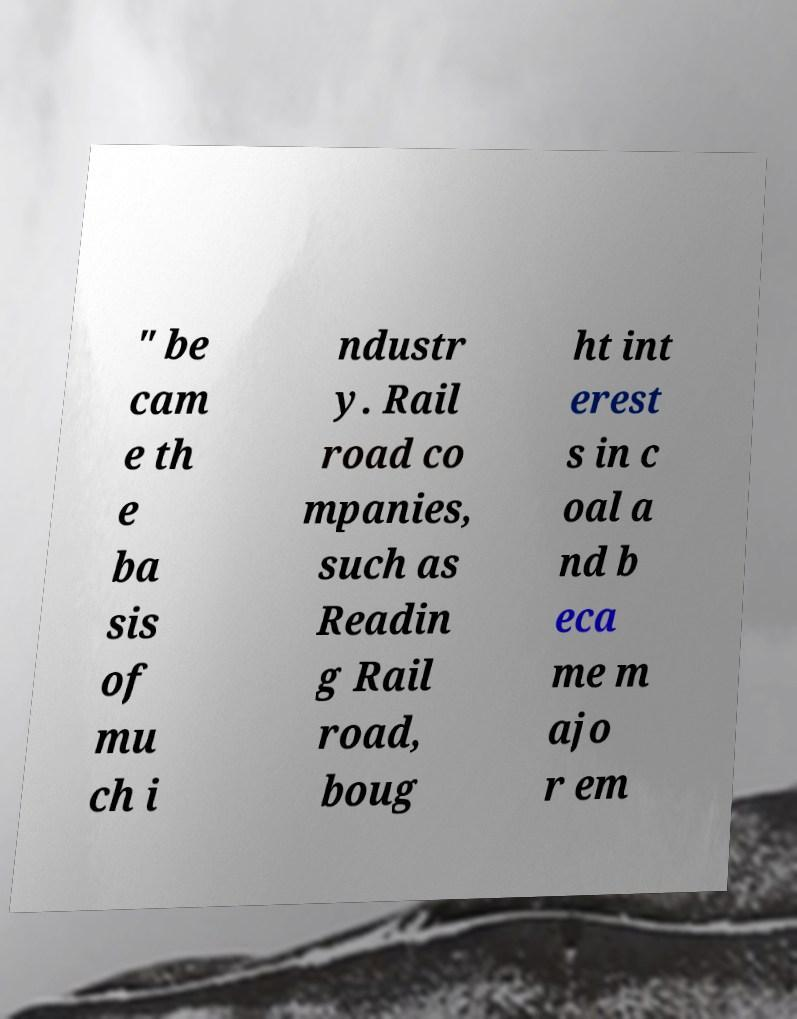Can you accurately transcribe the text from the provided image for me? " be cam e th e ba sis of mu ch i ndustr y. Rail road co mpanies, such as Readin g Rail road, boug ht int erest s in c oal a nd b eca me m ajo r em 